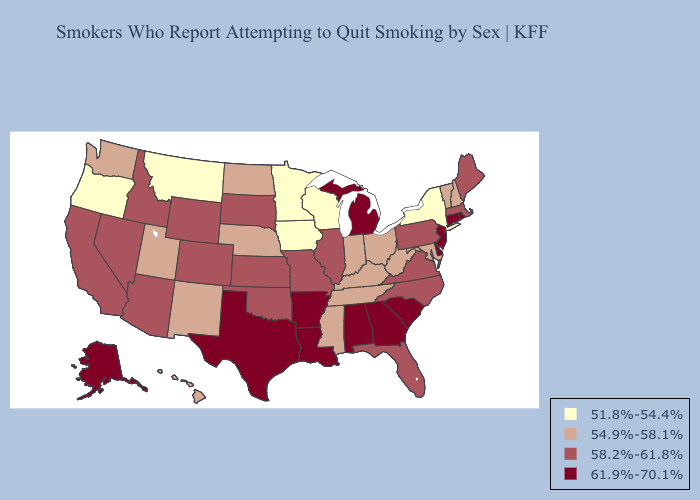What is the highest value in states that border Illinois?
Concise answer only. 58.2%-61.8%. Does Iowa have the highest value in the USA?
Concise answer only. No. Among the states that border Illinois , does Kentucky have the lowest value?
Concise answer only. No. Does Montana have the lowest value in the West?
Answer briefly. Yes. Which states have the lowest value in the Northeast?
Keep it brief. New York. What is the lowest value in states that border Mississippi?
Answer briefly. 54.9%-58.1%. Which states have the highest value in the USA?
Quick response, please. Alabama, Alaska, Arkansas, Connecticut, Delaware, Georgia, Louisiana, Michigan, New Jersey, Rhode Island, South Carolina, Texas. Name the states that have a value in the range 51.8%-54.4%?
Be succinct. Iowa, Minnesota, Montana, New York, Oregon, Wisconsin. What is the lowest value in the West?
Answer briefly. 51.8%-54.4%. Name the states that have a value in the range 54.9%-58.1%?
Short answer required. Hawaii, Indiana, Kentucky, Maryland, Mississippi, Nebraska, New Hampshire, New Mexico, North Dakota, Ohio, Tennessee, Utah, Vermont, Washington, West Virginia. What is the lowest value in states that border Wisconsin?
Be succinct. 51.8%-54.4%. Among the states that border Kansas , does Nebraska have the highest value?
Be succinct. No. Which states hav the highest value in the South?
Quick response, please. Alabama, Arkansas, Delaware, Georgia, Louisiana, South Carolina, Texas. Does the map have missing data?
Write a very short answer. No. Does Oregon have the lowest value in the USA?
Answer briefly. Yes. 